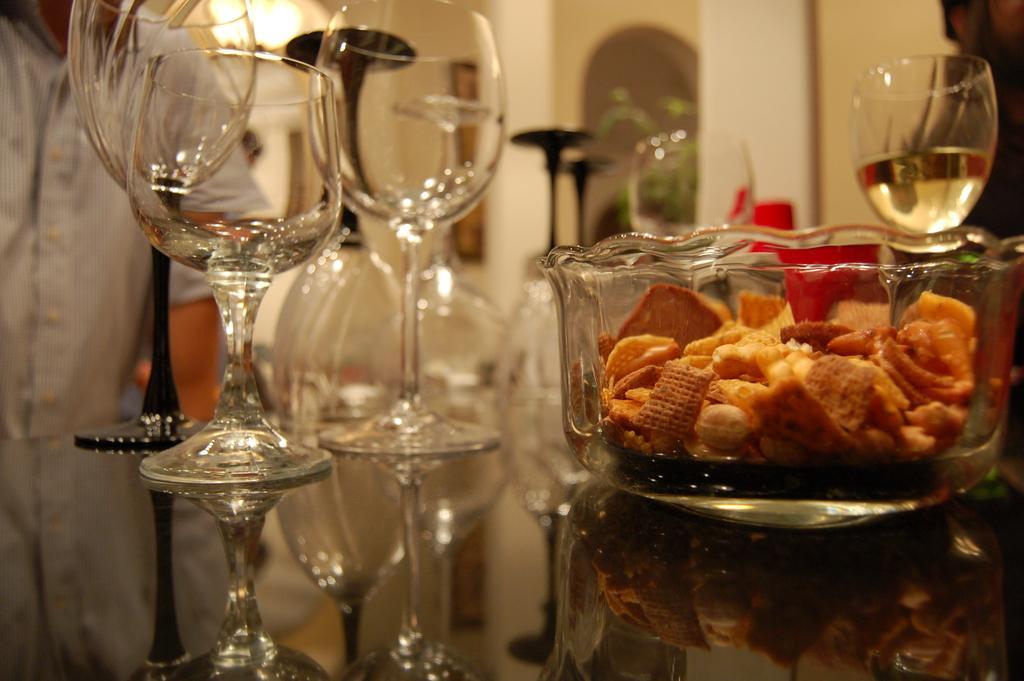How would you summarize this image in a sentence or two? In this image there are a few glasses, a bowl with food item arranged on the glass table, in front of the table there is a person. In the background there is a plant and a frame hanging on the wall. 